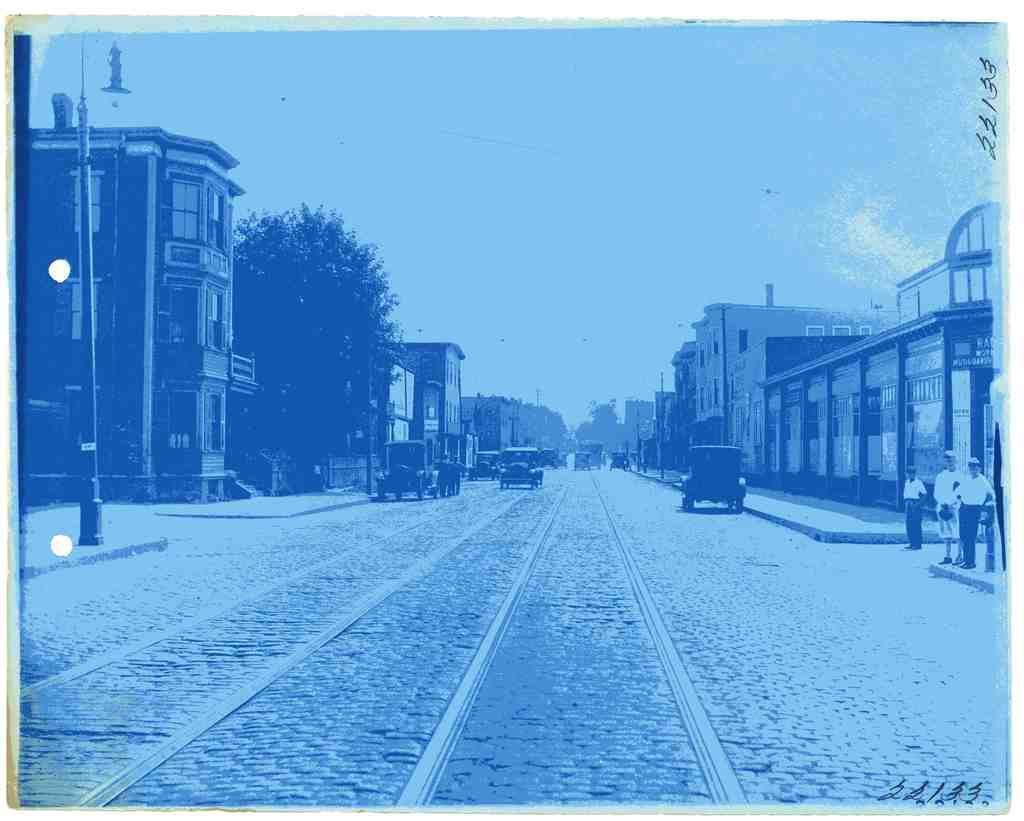How would you summarize this image in a sentence or two? In the image in the center we can see few vehicles on the road. And few people were standing. In the background we can see the sky,trees,buildings,poles,banners etc. 